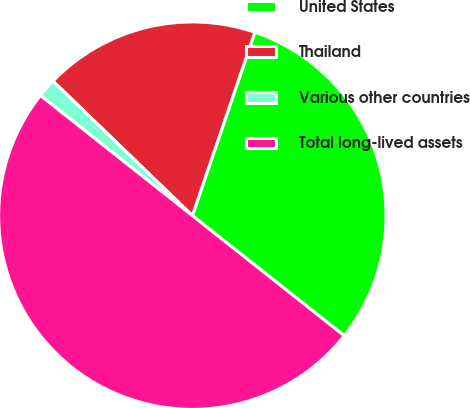<chart> <loc_0><loc_0><loc_500><loc_500><pie_chart><fcel>United States<fcel>Thailand<fcel>Various other countries<fcel>Total long-lived assets<nl><fcel>30.42%<fcel>18.01%<fcel>1.57%<fcel>50.0%<nl></chart> 